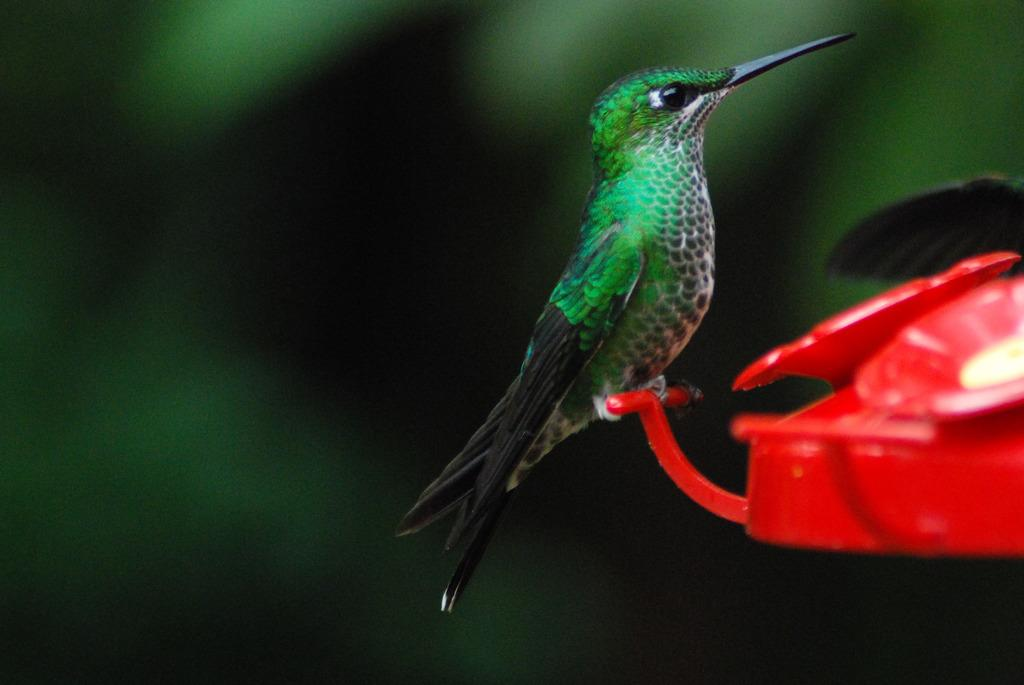What type of animal is in the image? There is a green color bird in the image. What is the bird sitting on? The bird is on a red color object. How would you describe the background of the image? The background of the image is blurred and dark. Can you see any ghosts interacting with the bird in the image? There are no ghosts present in the image. What type of eggnog is being served with the bird in the image? There is no eggnog present in the image. 